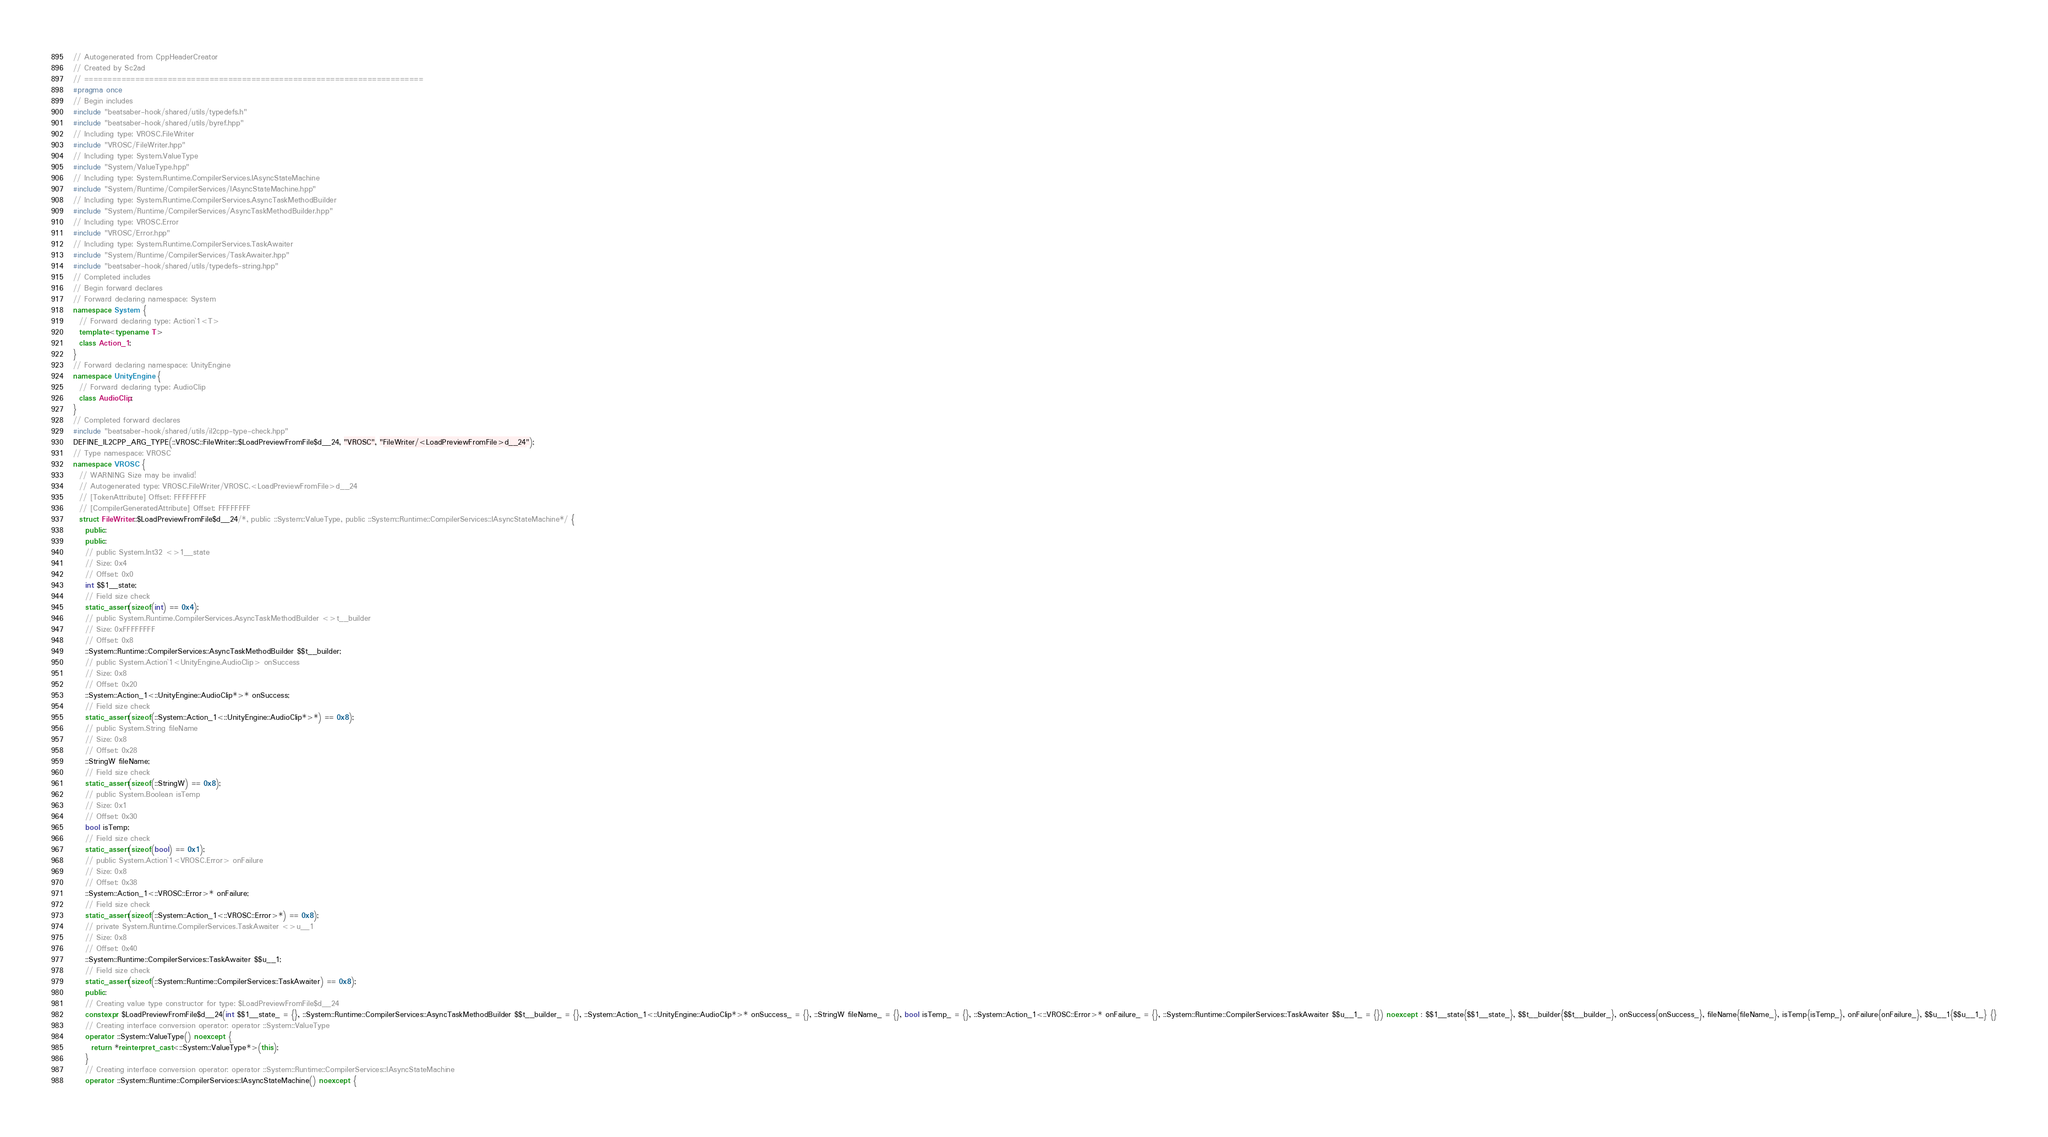<code> <loc_0><loc_0><loc_500><loc_500><_C++_>// Autogenerated from CppHeaderCreator
// Created by Sc2ad
// =========================================================================
#pragma once
// Begin includes
#include "beatsaber-hook/shared/utils/typedefs.h"
#include "beatsaber-hook/shared/utils/byref.hpp"
// Including type: VROSC.FileWriter
#include "VROSC/FileWriter.hpp"
// Including type: System.ValueType
#include "System/ValueType.hpp"
// Including type: System.Runtime.CompilerServices.IAsyncStateMachine
#include "System/Runtime/CompilerServices/IAsyncStateMachine.hpp"
// Including type: System.Runtime.CompilerServices.AsyncTaskMethodBuilder
#include "System/Runtime/CompilerServices/AsyncTaskMethodBuilder.hpp"
// Including type: VROSC.Error
#include "VROSC/Error.hpp"
// Including type: System.Runtime.CompilerServices.TaskAwaiter
#include "System/Runtime/CompilerServices/TaskAwaiter.hpp"
#include "beatsaber-hook/shared/utils/typedefs-string.hpp"
// Completed includes
// Begin forward declares
// Forward declaring namespace: System
namespace System {
  // Forward declaring type: Action`1<T>
  template<typename T>
  class Action_1;
}
// Forward declaring namespace: UnityEngine
namespace UnityEngine {
  // Forward declaring type: AudioClip
  class AudioClip;
}
// Completed forward declares
#include "beatsaber-hook/shared/utils/il2cpp-type-check.hpp"
DEFINE_IL2CPP_ARG_TYPE(::VROSC::FileWriter::$LoadPreviewFromFile$d__24, "VROSC", "FileWriter/<LoadPreviewFromFile>d__24");
// Type namespace: VROSC
namespace VROSC {
  // WARNING Size may be invalid!
  // Autogenerated type: VROSC.FileWriter/VROSC.<LoadPreviewFromFile>d__24
  // [TokenAttribute] Offset: FFFFFFFF
  // [CompilerGeneratedAttribute] Offset: FFFFFFFF
  struct FileWriter::$LoadPreviewFromFile$d__24/*, public ::System::ValueType, public ::System::Runtime::CompilerServices::IAsyncStateMachine*/ {
    public:
    public:
    // public System.Int32 <>1__state
    // Size: 0x4
    // Offset: 0x0
    int $$1__state;
    // Field size check
    static_assert(sizeof(int) == 0x4);
    // public System.Runtime.CompilerServices.AsyncTaskMethodBuilder <>t__builder
    // Size: 0xFFFFFFFF
    // Offset: 0x8
    ::System::Runtime::CompilerServices::AsyncTaskMethodBuilder $$t__builder;
    // public System.Action`1<UnityEngine.AudioClip> onSuccess
    // Size: 0x8
    // Offset: 0x20
    ::System::Action_1<::UnityEngine::AudioClip*>* onSuccess;
    // Field size check
    static_assert(sizeof(::System::Action_1<::UnityEngine::AudioClip*>*) == 0x8);
    // public System.String fileName
    // Size: 0x8
    // Offset: 0x28
    ::StringW fileName;
    // Field size check
    static_assert(sizeof(::StringW) == 0x8);
    // public System.Boolean isTemp
    // Size: 0x1
    // Offset: 0x30
    bool isTemp;
    // Field size check
    static_assert(sizeof(bool) == 0x1);
    // public System.Action`1<VROSC.Error> onFailure
    // Size: 0x8
    // Offset: 0x38
    ::System::Action_1<::VROSC::Error>* onFailure;
    // Field size check
    static_assert(sizeof(::System::Action_1<::VROSC::Error>*) == 0x8);
    // private System.Runtime.CompilerServices.TaskAwaiter <>u__1
    // Size: 0x8
    // Offset: 0x40
    ::System::Runtime::CompilerServices::TaskAwaiter $$u__1;
    // Field size check
    static_assert(sizeof(::System::Runtime::CompilerServices::TaskAwaiter) == 0x8);
    public:
    // Creating value type constructor for type: $LoadPreviewFromFile$d__24
    constexpr $LoadPreviewFromFile$d__24(int $$1__state_ = {}, ::System::Runtime::CompilerServices::AsyncTaskMethodBuilder $$t__builder_ = {}, ::System::Action_1<::UnityEngine::AudioClip*>* onSuccess_ = {}, ::StringW fileName_ = {}, bool isTemp_ = {}, ::System::Action_1<::VROSC::Error>* onFailure_ = {}, ::System::Runtime::CompilerServices::TaskAwaiter $$u__1_ = {}) noexcept : $$1__state{$$1__state_}, $$t__builder{$$t__builder_}, onSuccess{onSuccess_}, fileName{fileName_}, isTemp{isTemp_}, onFailure{onFailure_}, $$u__1{$$u__1_} {}
    // Creating interface conversion operator: operator ::System::ValueType
    operator ::System::ValueType() noexcept {
      return *reinterpret_cast<::System::ValueType*>(this);
    }
    // Creating interface conversion operator: operator ::System::Runtime::CompilerServices::IAsyncStateMachine
    operator ::System::Runtime::CompilerServices::IAsyncStateMachine() noexcept {</code> 